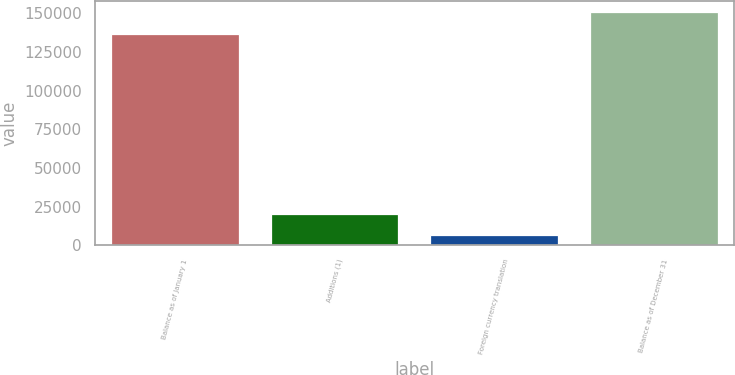<chart> <loc_0><loc_0><loc_500><loc_500><bar_chart><fcel>Balance as of January 1<fcel>Additions (1)<fcel>Foreign currency translation<fcel>Balance as of December 31<nl><fcel>136952<fcel>20445.4<fcel>6673<fcel>150724<nl></chart> 